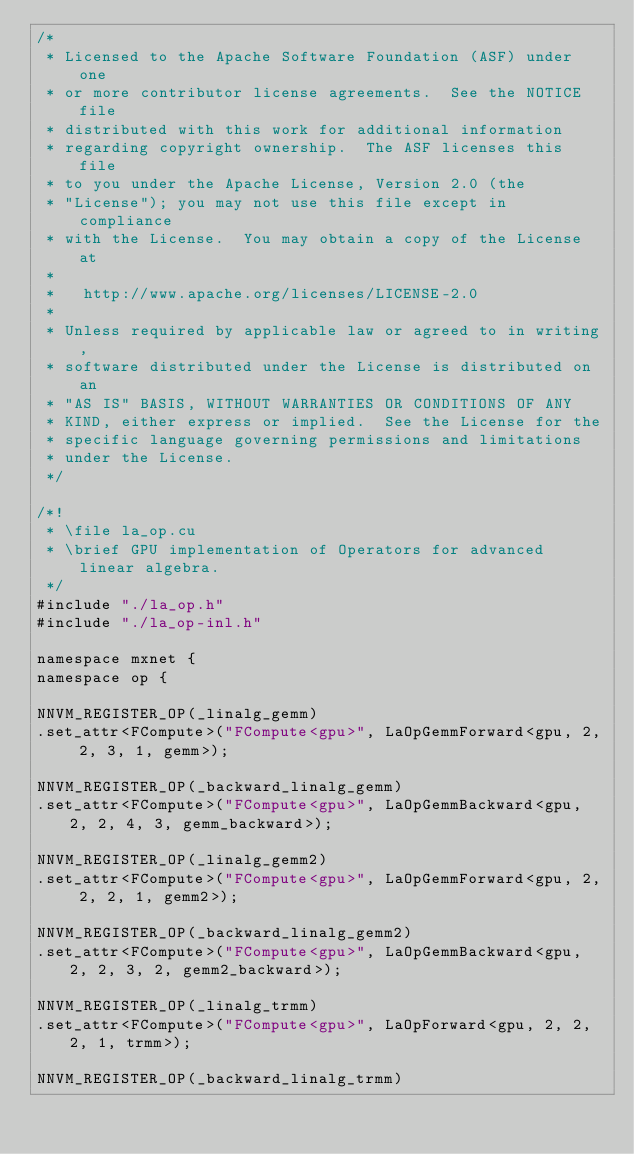<code> <loc_0><loc_0><loc_500><loc_500><_Cuda_>/*
 * Licensed to the Apache Software Foundation (ASF) under one
 * or more contributor license agreements.  See the NOTICE file
 * distributed with this work for additional information
 * regarding copyright ownership.  The ASF licenses this file
 * to you under the Apache License, Version 2.0 (the
 * "License"); you may not use this file except in compliance
 * with the License.  You may obtain a copy of the License at
 *
 *   http://www.apache.org/licenses/LICENSE-2.0
 *
 * Unless required by applicable law or agreed to in writing,
 * software distributed under the License is distributed on an
 * "AS IS" BASIS, WITHOUT WARRANTIES OR CONDITIONS OF ANY
 * KIND, either express or implied.  See the License for the
 * specific language governing permissions and limitations
 * under the License.
 */

/*!
 * \file la_op.cu
 * \brief GPU implementation of Operators for advanced linear algebra.
 */
#include "./la_op.h"
#include "./la_op-inl.h"

namespace mxnet {
namespace op {

NNVM_REGISTER_OP(_linalg_gemm)
.set_attr<FCompute>("FCompute<gpu>", LaOpGemmForward<gpu, 2, 2, 3, 1, gemm>);

NNVM_REGISTER_OP(_backward_linalg_gemm)
.set_attr<FCompute>("FCompute<gpu>", LaOpGemmBackward<gpu, 2, 2, 4, 3, gemm_backward>);

NNVM_REGISTER_OP(_linalg_gemm2)
.set_attr<FCompute>("FCompute<gpu>", LaOpGemmForward<gpu, 2, 2, 2, 1, gemm2>);

NNVM_REGISTER_OP(_backward_linalg_gemm2)
.set_attr<FCompute>("FCompute<gpu>", LaOpGemmBackward<gpu, 2, 2, 3, 2, gemm2_backward>);

NNVM_REGISTER_OP(_linalg_trmm)
.set_attr<FCompute>("FCompute<gpu>", LaOpForward<gpu, 2, 2, 2, 1, trmm>);

NNVM_REGISTER_OP(_backward_linalg_trmm)</code> 